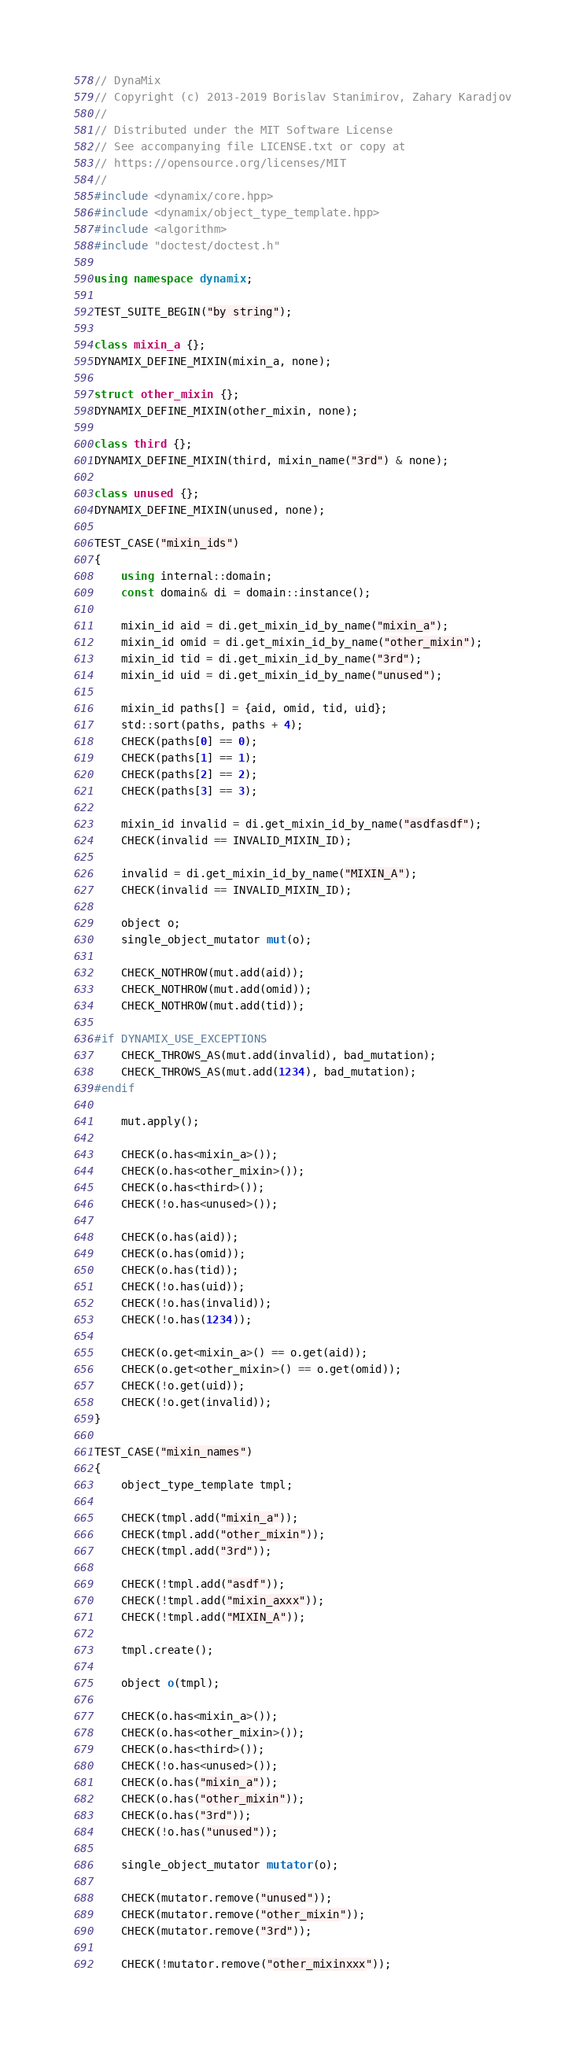Convert code to text. <code><loc_0><loc_0><loc_500><loc_500><_C++_>// DynaMix
// Copyright (c) 2013-2019 Borislav Stanimirov, Zahary Karadjov
//
// Distributed under the MIT Software License
// See accompanying file LICENSE.txt or copy at
// https://opensource.org/licenses/MIT
//
#include <dynamix/core.hpp>
#include <dynamix/object_type_template.hpp>
#include <algorithm>
#include "doctest/doctest.h"

using namespace dynamix;

TEST_SUITE_BEGIN("by string");

class mixin_a {};
DYNAMIX_DEFINE_MIXIN(mixin_a, none);

struct other_mixin {};
DYNAMIX_DEFINE_MIXIN(other_mixin, none);

class third {};
DYNAMIX_DEFINE_MIXIN(third, mixin_name("3rd") & none);

class unused {};
DYNAMIX_DEFINE_MIXIN(unused, none);

TEST_CASE("mixin_ids")
{
    using internal::domain;
    const domain& di = domain::instance();

    mixin_id aid = di.get_mixin_id_by_name("mixin_a");
    mixin_id omid = di.get_mixin_id_by_name("other_mixin");
    mixin_id tid = di.get_mixin_id_by_name("3rd");
    mixin_id uid = di.get_mixin_id_by_name("unused");

    mixin_id paths[] = {aid, omid, tid, uid};
    std::sort(paths, paths + 4);
    CHECK(paths[0] == 0);
    CHECK(paths[1] == 1);
    CHECK(paths[2] == 2);
    CHECK(paths[3] == 3);

    mixin_id invalid = di.get_mixin_id_by_name("asdfasdf");
    CHECK(invalid == INVALID_MIXIN_ID);

    invalid = di.get_mixin_id_by_name("MIXIN_A");
    CHECK(invalid == INVALID_MIXIN_ID);

    object o;
    single_object_mutator mut(o);

    CHECK_NOTHROW(mut.add(aid));
    CHECK_NOTHROW(mut.add(omid));
    CHECK_NOTHROW(mut.add(tid));

#if DYNAMIX_USE_EXCEPTIONS
    CHECK_THROWS_AS(mut.add(invalid), bad_mutation);
    CHECK_THROWS_AS(mut.add(1234), bad_mutation);
#endif

    mut.apply();

    CHECK(o.has<mixin_a>());
    CHECK(o.has<other_mixin>());
    CHECK(o.has<third>());
    CHECK(!o.has<unused>());

    CHECK(o.has(aid));
    CHECK(o.has(omid));
    CHECK(o.has(tid));
    CHECK(!o.has(uid));
    CHECK(!o.has(invalid));
    CHECK(!o.has(1234));

    CHECK(o.get<mixin_a>() == o.get(aid));
    CHECK(o.get<other_mixin>() == o.get(omid));
    CHECK(!o.get(uid));
    CHECK(!o.get(invalid));
}

TEST_CASE("mixin_names")
{
    object_type_template tmpl;

    CHECK(tmpl.add("mixin_a"));
    CHECK(tmpl.add("other_mixin"));
    CHECK(tmpl.add("3rd"));

    CHECK(!tmpl.add("asdf"));
    CHECK(!tmpl.add("mixin_axxx"));
    CHECK(!tmpl.add("MIXIN_A"));

    tmpl.create();

    object o(tmpl);

    CHECK(o.has<mixin_a>());
    CHECK(o.has<other_mixin>());
    CHECK(o.has<third>());
    CHECK(!o.has<unused>());
    CHECK(o.has("mixin_a"));
    CHECK(o.has("other_mixin"));
    CHECK(o.has("3rd"));
    CHECK(!o.has("unused"));

    single_object_mutator mutator(o);

    CHECK(mutator.remove("unused"));
    CHECK(mutator.remove("other_mixin"));
    CHECK(mutator.remove("3rd"));

    CHECK(!mutator.remove("other_mixinxxx"));</code> 